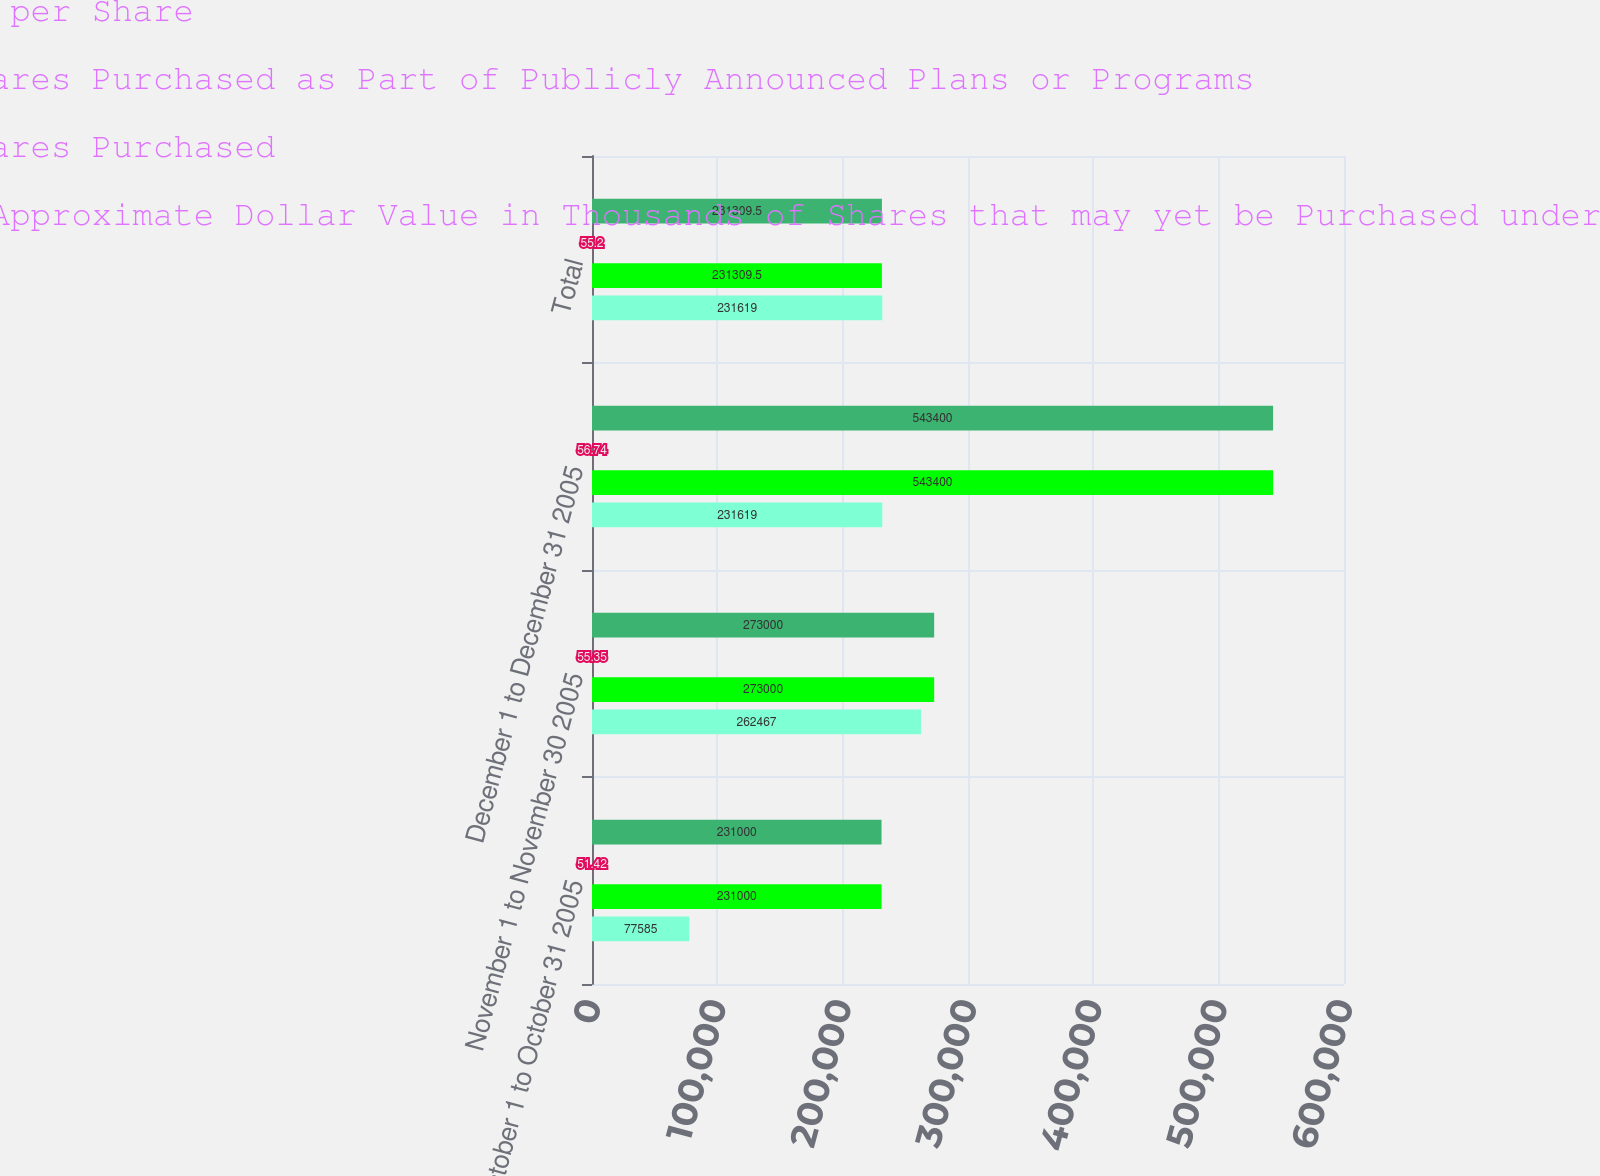<chart> <loc_0><loc_0><loc_500><loc_500><stacked_bar_chart><ecel><fcel>October 1 to October 31 2005<fcel>November 1 to November 30 2005<fcel>December 1 to December 31 2005<fcel>Total<nl><fcel>b Average Price Paid per Share<fcel>231000<fcel>273000<fcel>543400<fcel>231310<nl><fcel>c Total Number of Shares Purchased as Part of Publicly Announced Plans or Programs<fcel>51.42<fcel>55.35<fcel>56.74<fcel>55.2<nl><fcel>a Total Number of Shares Purchased<fcel>231000<fcel>273000<fcel>543400<fcel>231310<nl><fcel>d Maximum Number or Approximate Dollar Value in Thousands of Shares that may yet be Purchased under the Plans or Programs<fcel>77585<fcel>262467<fcel>231619<fcel>231619<nl></chart> 